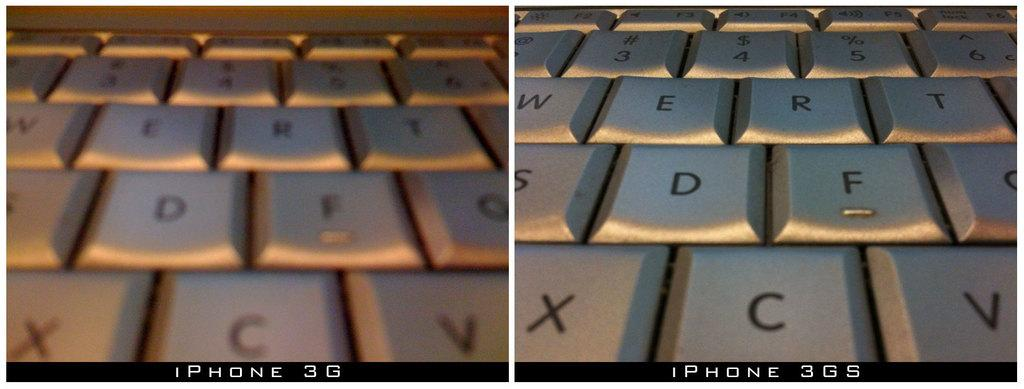<image>
Share a concise interpretation of the image provided. A close up picture is of a keyboard with several keys shown such as D anf F. 